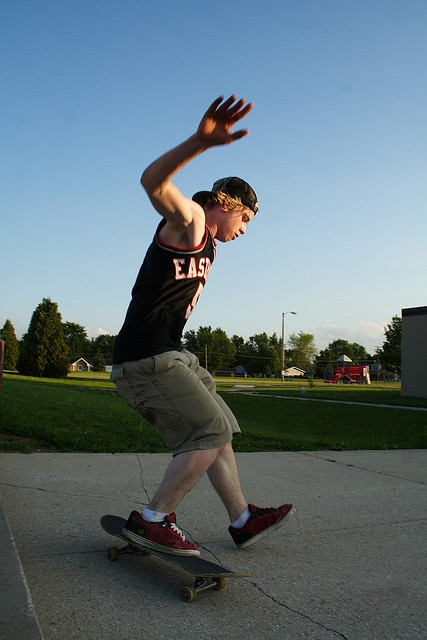Describe the objects in this image and their specific colors. I can see people in gray, black, and maroon tones, skateboard in gray and black tones, and bench in gray, darkgreen, and darkgray tones in this image. 